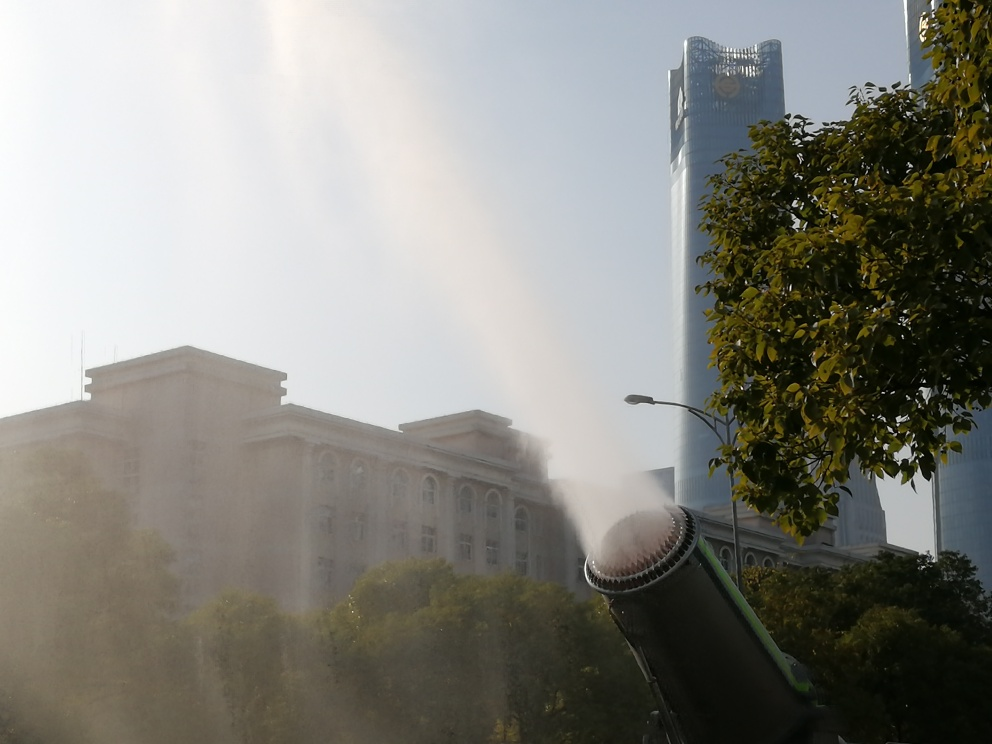What is happening in this image? It appears to be an urban scene where a water cannon is actively spraying water into the air, creating a mist that partially obscures the buildings in the background. The contrasting architectures suggest a dynamic cityscape. What might be the purpose of the water cannon in this context? Water cannons can be used for various purposes, such as crowd control, firefighting, or cleaning streets. In this context, without additional information, it's difficult to determine the exact purpose. It might be part of a cleaning operation or perhaps even a cooling mechanism if the weather is particularly hot. 